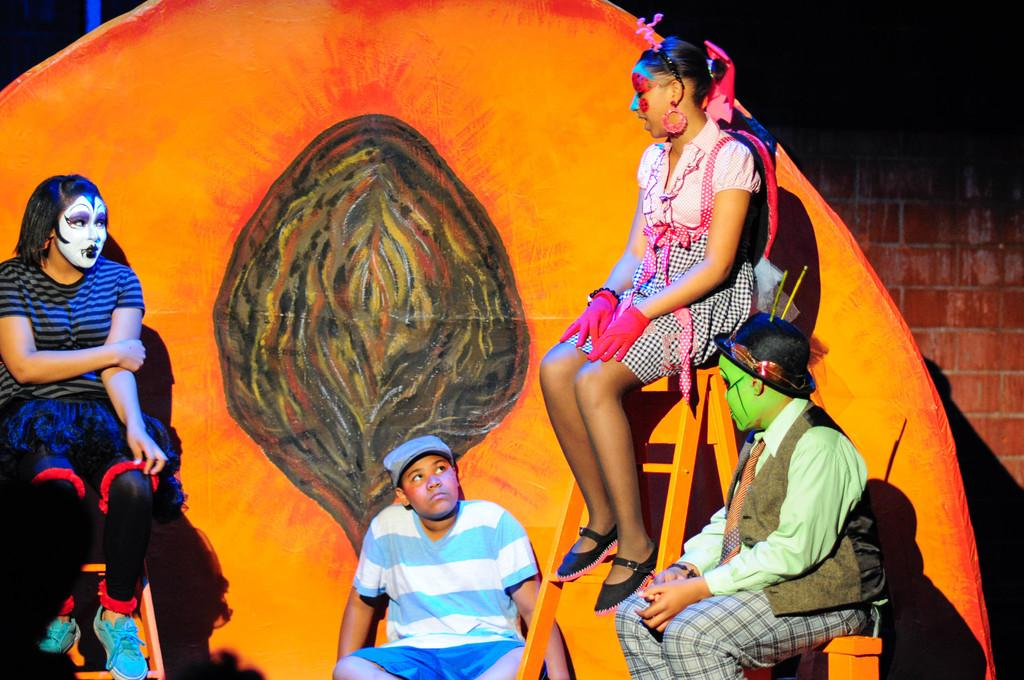What is happening in the image? There is a group of people in the image, and they are sitting. What can be seen on the faces of the people in the image? There is a painting on their faces. What is visible in the background of the image? There is a brick wall in the background of the image. What type of bead is being used to create the painting on the people's faces in the image? There is no mention of beads being used in the image; the painting on their faces is not described in detail. 